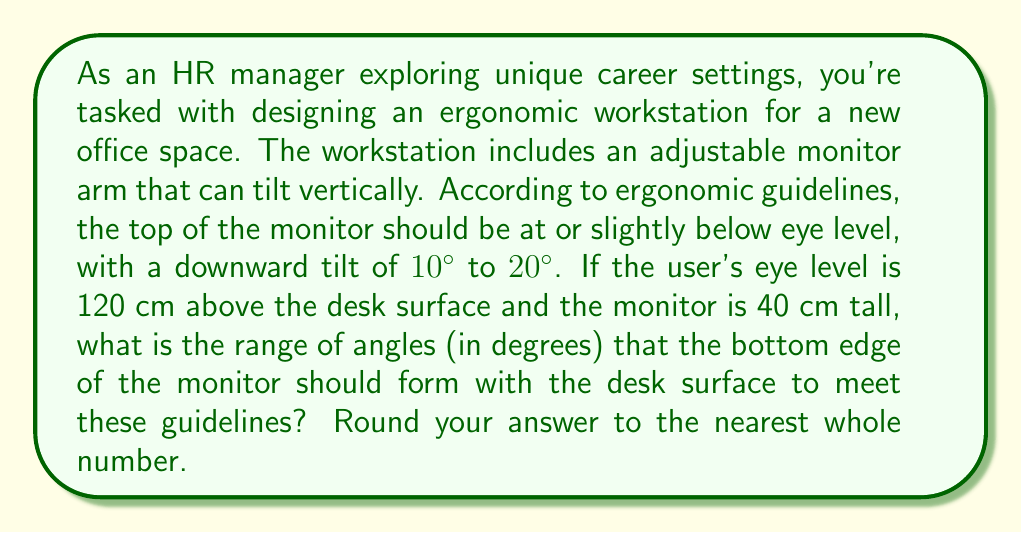Provide a solution to this math problem. Let's approach this step-by-step:

1) First, let's visualize the setup:
   [asy]
   import geometry;
   
   pair A = (0,0), B = (100,120), C = (100,80), D = (100,0);
   draw(A--B--C--D--A);
   draw(A--C,dashed);
   label("Desk", (50,0), S);
   label("Eye level", B, E);
   label("Monitor", (100,100), E);
   label("120 cm", (0,60), W);
   label("40 cm", (100,100), E);
   label("$\theta$", (20,20), NW);
   [/asy]

2) The monitor's top edge should be between 0 and 10 cm below eye level (10% of 120 cm is 12 cm, but we'll use 10 cm for a round number).

3) Let's calculate the angles for both extremes:

   Case 1 (monitor top at eye level):
   - The bottom of the monitor is 40 cm below eye level
   - We can form a right triangle with:
     * Adjacent side = 100 cm (assumed desk depth)
     * Opposite side = 40 cm
   - The angle $\theta$ is given by:
     $$\theta = \tan^{-1}(\frac{40}{100}) \approx 21.8°$$

   Case 2 (monitor top 10 cm below eye level):
   - The bottom of the monitor is 50 cm below eye level
   - We form a right triangle with:
     * Adjacent side = 100 cm
     * Opposite side = 50 cm
   - The angle $\theta$ is given by:
     $$\theta = \tan^{-1}(\frac{50}{100}) = 26.6°$$

4) To account for the 10° to 20° downward tilt of the monitor itself, we need to subtract this range from our calculated angles:

   Case 1: 21.8° - 20° = 1.8° to 21.8° - 10° = 11.8°
   Case 2: 26.6° - 20° = 6.6° to 26.6° - 10° = 16.6°

5) Combining these ranges and rounding to the nearest whole number:
   2° to 17°
Answer: 2° to 17° 